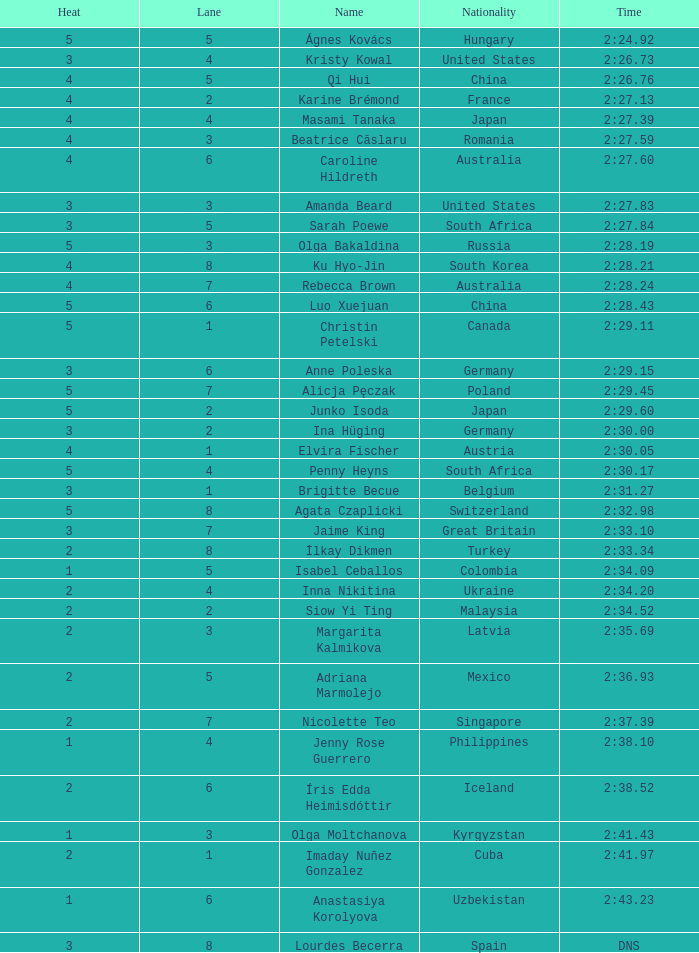What is the title that observed 4 temperature increases and a route greater than 7? Ku Hyo-Jin. 